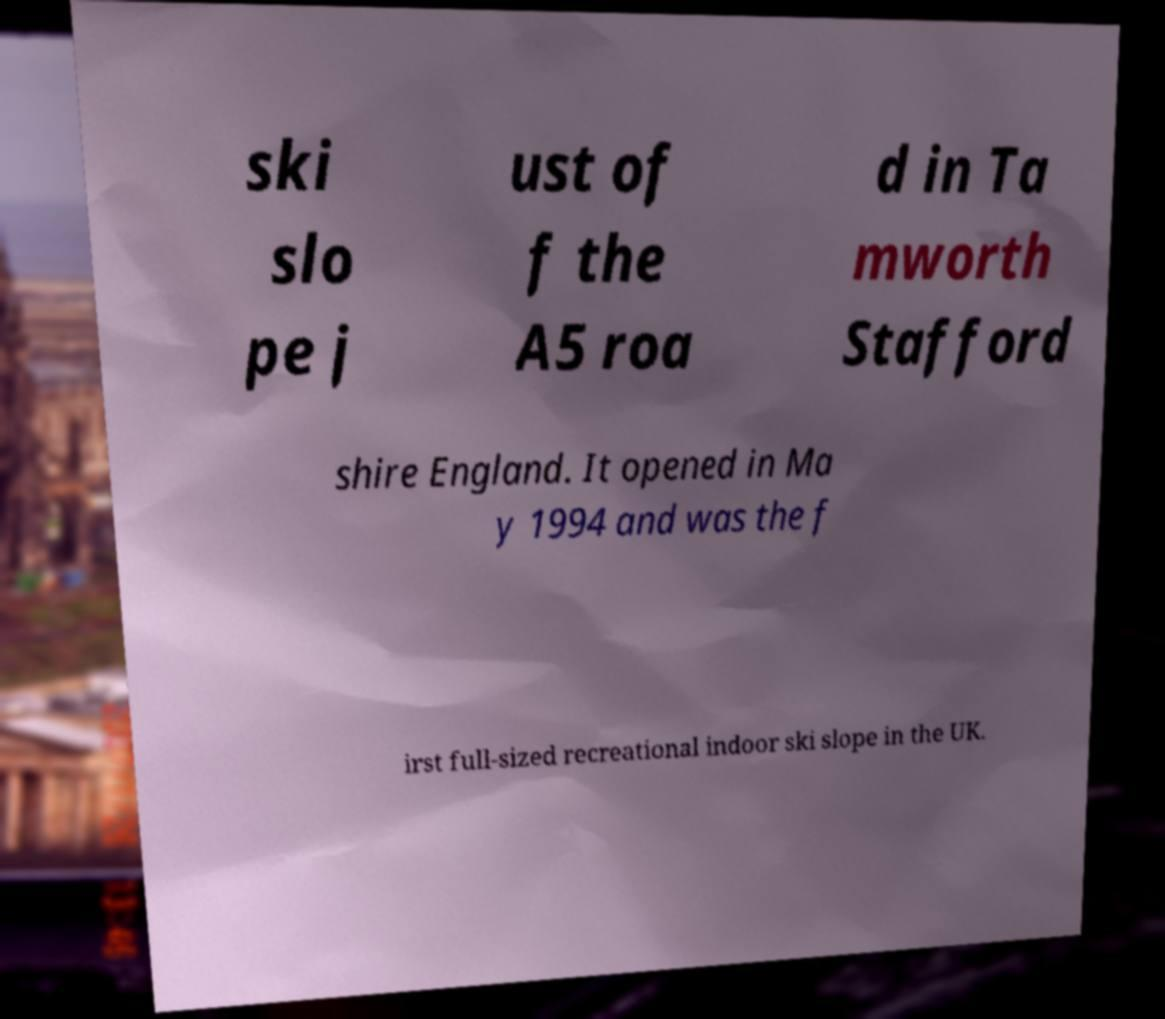There's text embedded in this image that I need extracted. Can you transcribe it verbatim? ski slo pe j ust of f the A5 roa d in Ta mworth Stafford shire England. It opened in Ma y 1994 and was the f irst full-sized recreational indoor ski slope in the UK. 